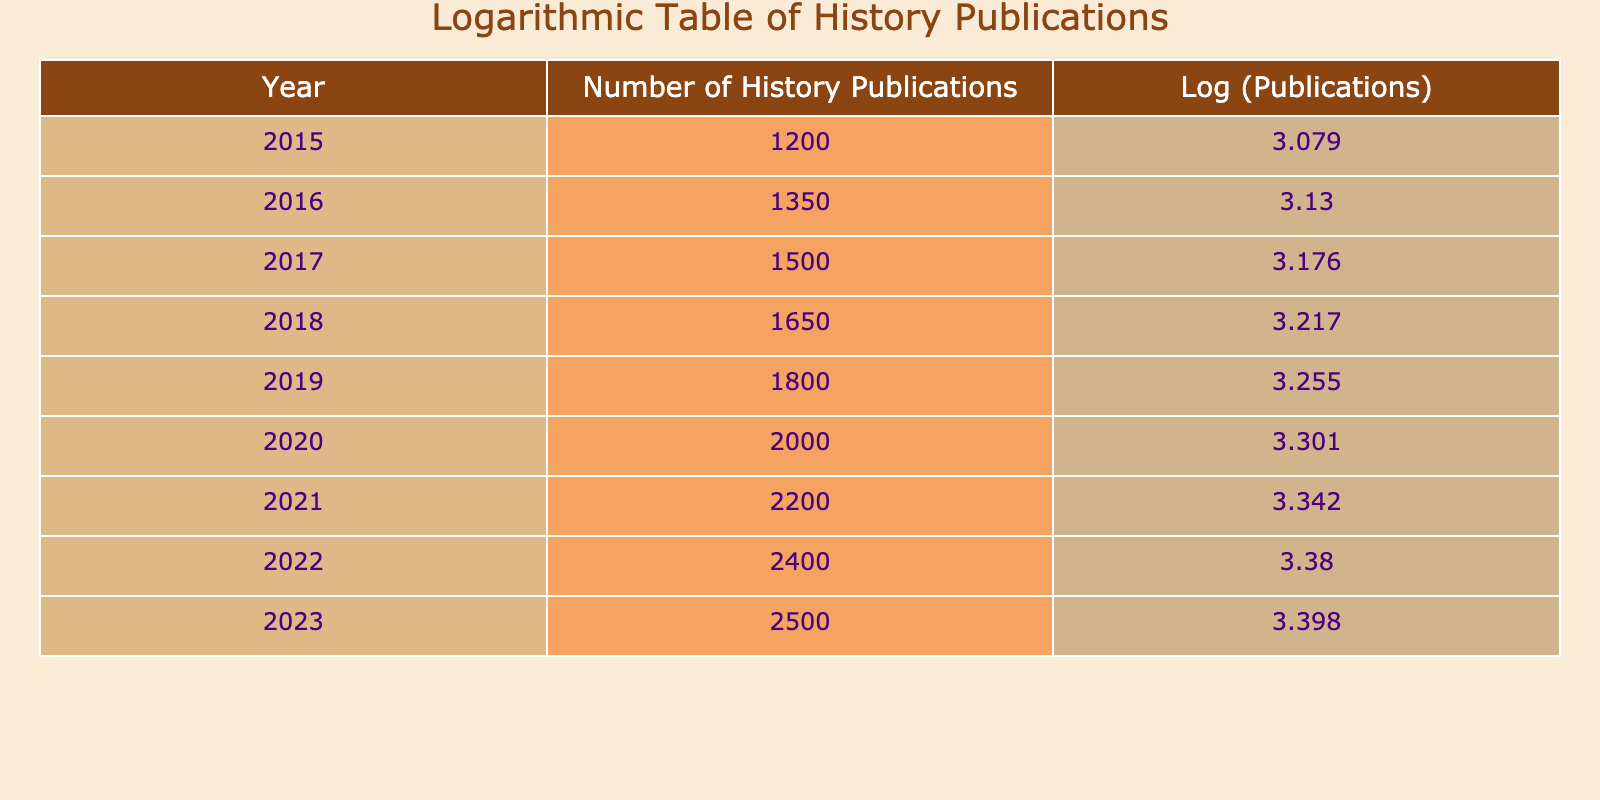What was the number of history publications in 2020? The value for history publications in the year 2020 can be directly found in the table. It states that there were 2000 publications in that year.
Answer: 2000 What is the logarithmic value of history publications in 2022? The logarithmic value for the year 2022 is listed in the table. It shows a log value of approximately 3.38, calculated from the actual number of 2400 publications.
Answer: 3.38 How many more history publications were there in 2021 compared to 2019? To find the difference, I first look up the publications for both years. In 2021, there were 2200 publications, and in 2019, there were 1800. The difference is 2200 - 1800 = 400.
Answer: 400 What was the average number of history publications from 2015 to 2018? To calculate the average, I sum the publications for the years 2015 (1200), 2016 (1350), 2017 (1500), and 2018 (1650). The total is 1200 + 1350 + 1500 + 1650 = 5700. Since there are 4 years, I divide 5700 by 4, which gives me 1425.
Answer: 1425 Are there more than 2300 publications in 2023? Looking at the table, it states that there were 2500 publications in 2023, which is indeed more than 2300.
Answer: Yes What is the percentage increase in publications from 2015 to 2023? First, I find the number of publications in both years: 1200 for 2015 and 2500 for 2023. The increase is 2500 - 1200 = 1300. To get the percentage increase, I divide by the original number (1200): (1300 / 1200) * 100, which equals approximately 108.33%.
Answer: 108.33% What is the median number of history publications from 2015 to 2023? To find the median, I list all the publication numbers in order: 1200, 1350, 1500, 1650, 1800, 2000, 2200, 2400, 2500. As there are 9 numbers, the median is the middle one, which is the 5th number: 1800.
Answer: 1800 Did the number of history publications decrease in any year from 2015 to 2023? Looking at the table, the number of publications consistently increases each year. There are no instances in which the number decreases.
Answer: No What was the increase in logarithmic value of publications from 2020 to 2022? First, I look at the logarithmic values: for 2020, it is approximately 3.301, and for 2022, it is approximately 3.38. The increase is 3.38 - 3.301 = 0.079.
Answer: 0.079 